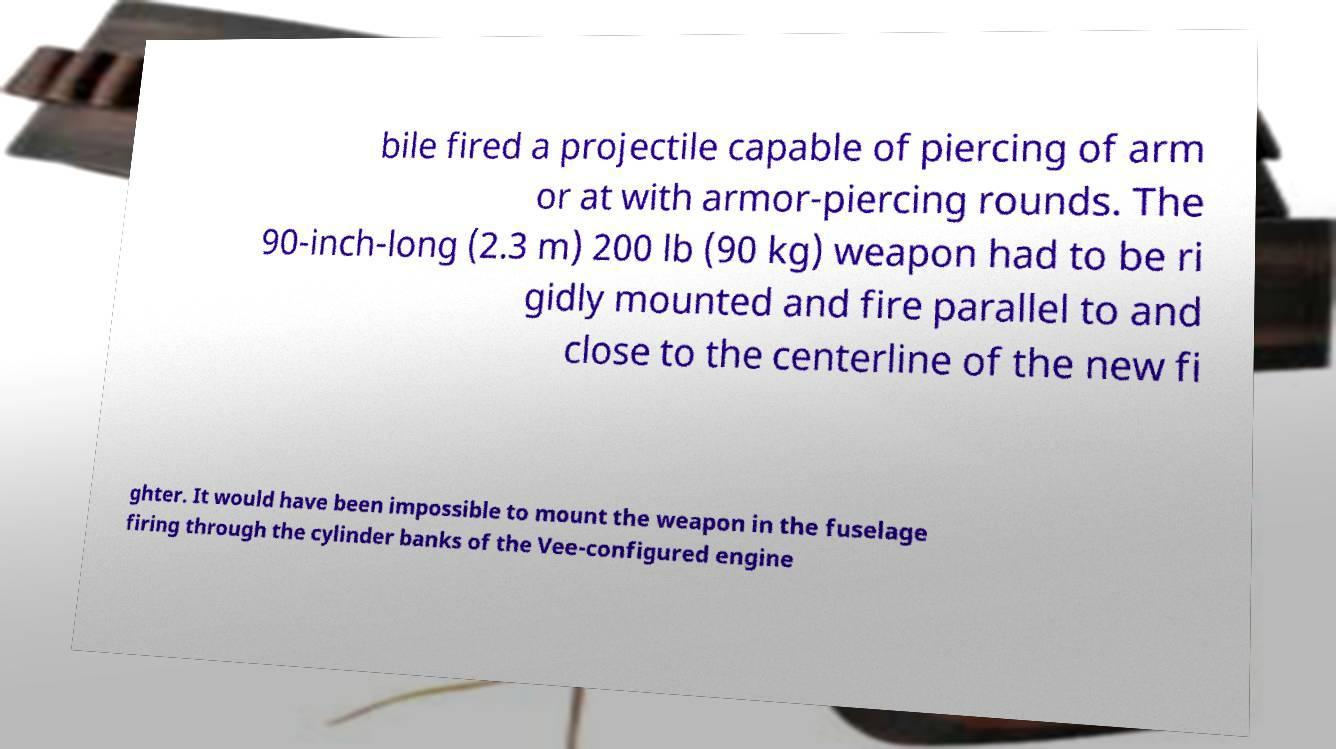Can you read and provide the text displayed in the image?This photo seems to have some interesting text. Can you extract and type it out for me? bile fired a projectile capable of piercing of arm or at with armor-piercing rounds. The 90-inch-long (2.3 m) 200 lb (90 kg) weapon had to be ri gidly mounted and fire parallel to and close to the centerline of the new fi ghter. It would have been impossible to mount the weapon in the fuselage firing through the cylinder banks of the Vee-configured engine 